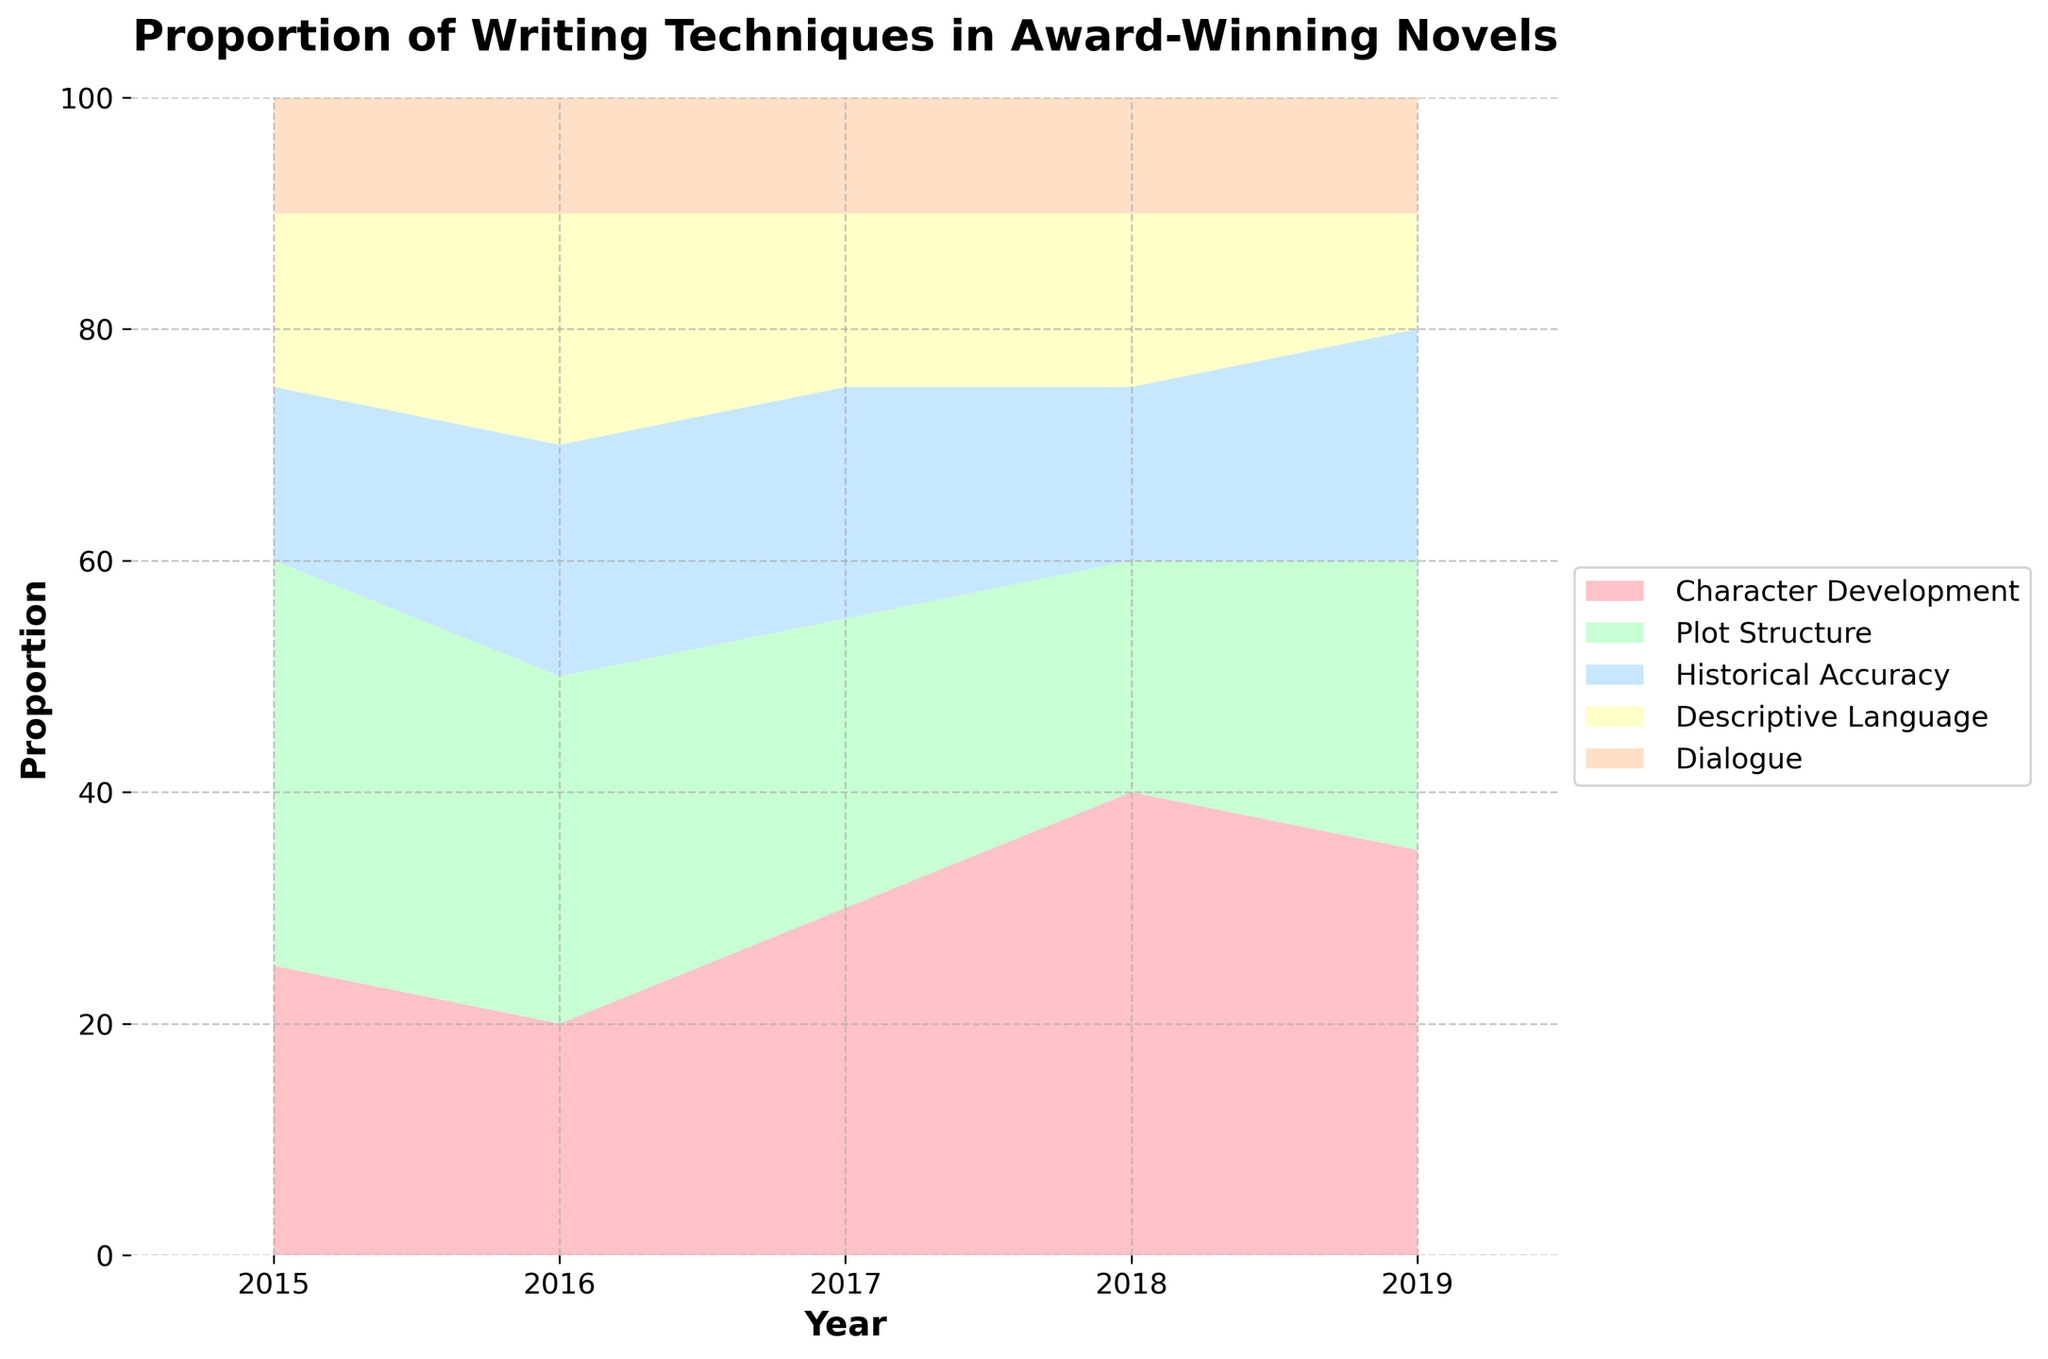What is the title of the figure? The title of the figure is written at the top and describes the overall content. It reads 'Proportion of Writing Techniques in Award-Winning Novels'.
Answer: Proportion of Writing Techniques in Award-Winning Novels Which technique had the highest proportion in 2018? To find the highest proportion for 2018, look at the 2018 vertical line and identify which section has the largest area. Character Development appears to occupy the largest proportion.
Answer: Character Development How did the proportion of Plot Structure change from 2015 to 2019? To track the change, observe the size of the Plot Structure area from 2015 to 2019. It begins at a higher proportion in 2015 and seems to decrease then slightly rise.
Answer: Decreased then slightly increased Which technique showed a steady proportion throughout the years? Look for a section with relatively stable width across the years. Dialogue appears to maintain a fairly constant proportion.
Answer: Dialogue In which year did Character Development peak? Identify where the section representing Character Development reaches its maximum width along the x-axis. This peak occurs in 2018.
Answer: 2018 Compare the proportions of Historical Accuracy and Descriptive Language in 2016. Find the 2016 vertical and compare the sizes of the sections for Historical Accuracy and Descriptive Language. Historical Accuracy has a slightly larger proportion than Descriptive Language.
Answer: Historical Accuracy is greater What is the approximate proportion of Descriptive Language in 2019? Follow the vertical line for the year 2019 and estimate the height of the Descriptive Language section. It appears to be about 10%.
Answer: 10% Which year had the lowest proportion for Plot Structure? Compare the corresponding section for Plot Structure across all years and find the smallest. In 2018, Plot Structure is at its minimum.
Answer: 2018 What can you infer about the trend of Character Development from 2015 to 2019? Observe the Character Development's section over the years. It generally increases from 2015 to 2019.
Answer: Increasing What is the combined proportion of Historical Accuracy and Dialogue in 2015? Sum the sections for Historical Accuracy and Dialogue for the year 2015: 15% (Historical Accuracy) + 10% (Dialogue) = 25%.
Answer: 25% 